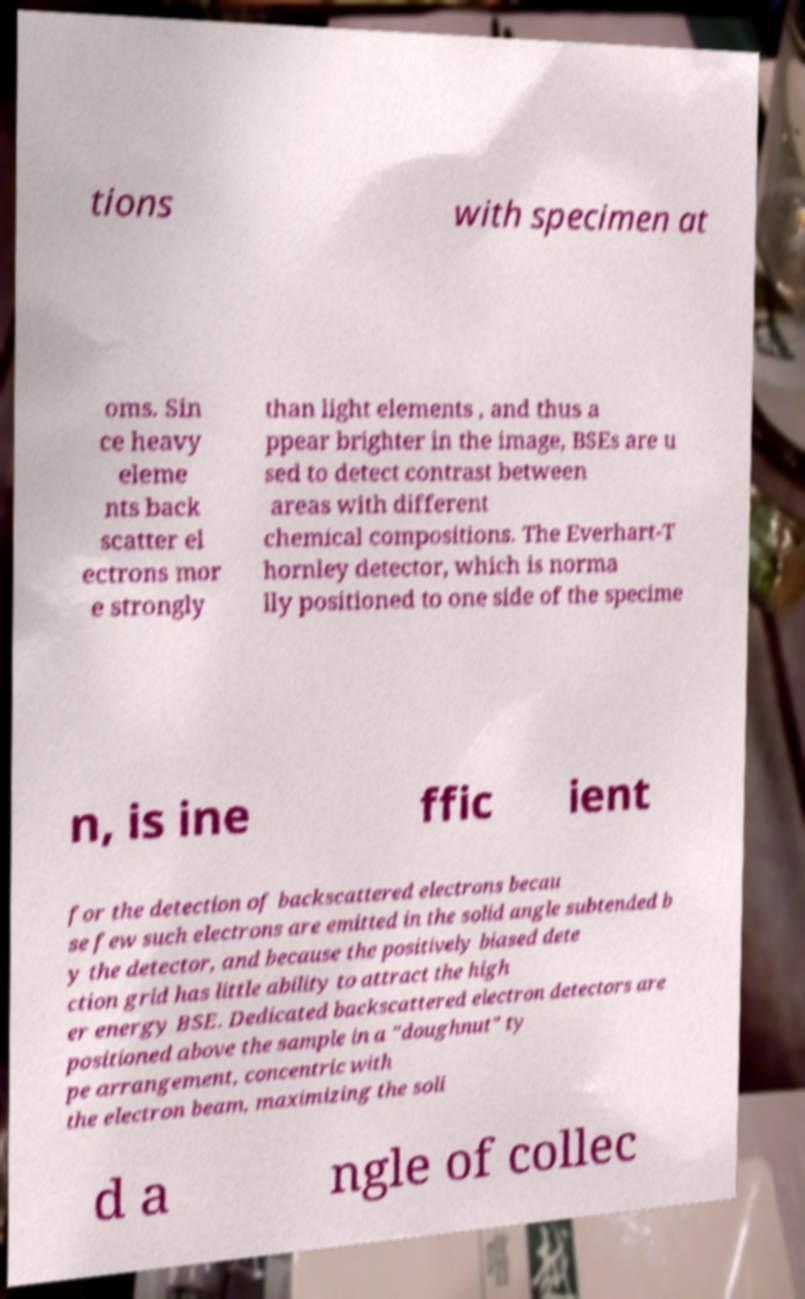Please identify and transcribe the text found in this image. tions with specimen at oms. Sin ce heavy eleme nts back scatter el ectrons mor e strongly than light elements , and thus a ppear brighter in the image, BSEs are u sed to detect contrast between areas with different chemical compositions. The Everhart-T hornley detector, which is norma lly positioned to one side of the specime n, is ine ffic ient for the detection of backscattered electrons becau se few such electrons are emitted in the solid angle subtended b y the detector, and because the positively biased dete ction grid has little ability to attract the high er energy BSE. Dedicated backscattered electron detectors are positioned above the sample in a "doughnut" ty pe arrangement, concentric with the electron beam, maximizing the soli d a ngle of collec 